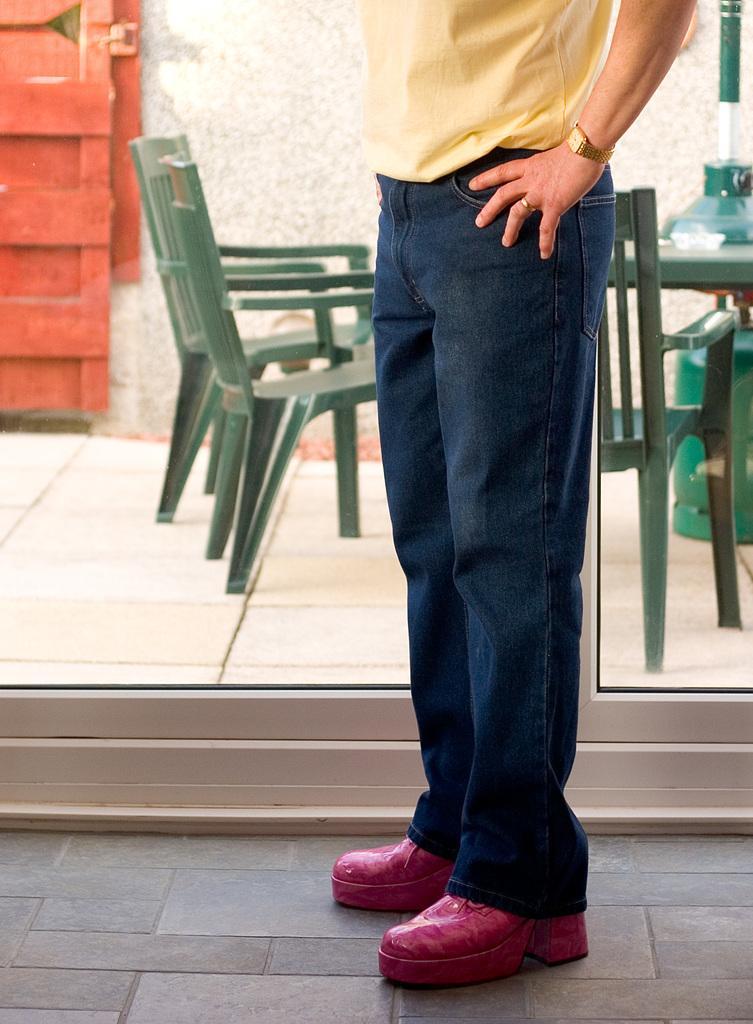How would you summarize this image in a sentence or two? In the picture we can see a person standing on the floor with yellow T-shirt, black trouser, and dark pink shoes and behind the person we can see a white color floor with green color chairs and behind it we can see the wall and red color door. 